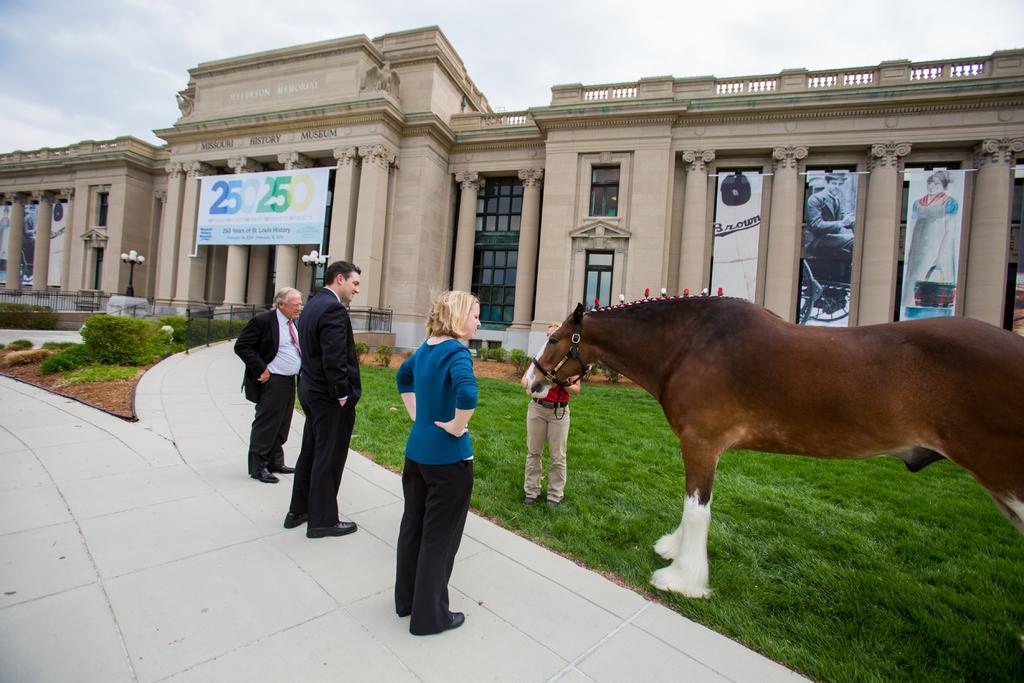Please provide a concise description of this image. As we can see in the image there is a sky, building, banner, a window, door, grass, plants, for people over here and there is a brown color horse. 